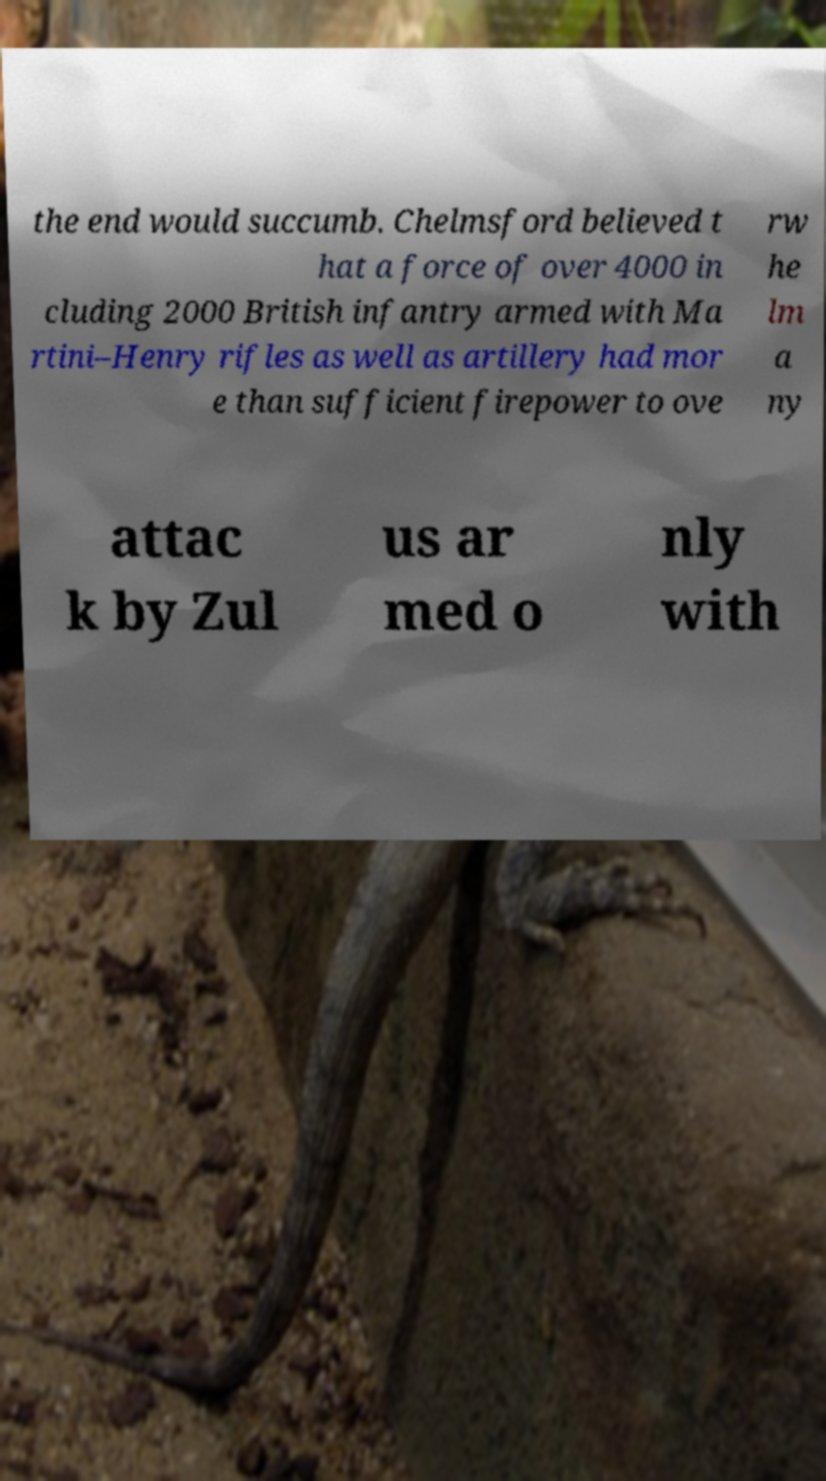I need the written content from this picture converted into text. Can you do that? the end would succumb. Chelmsford believed t hat a force of over 4000 in cluding 2000 British infantry armed with Ma rtini–Henry rifles as well as artillery had mor e than sufficient firepower to ove rw he lm a ny attac k by Zul us ar med o nly with 